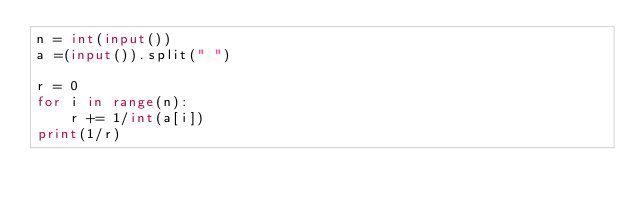<code> <loc_0><loc_0><loc_500><loc_500><_Python_>n = int(input())
a =(input()).split(" ")

r = 0
for i in range(n):
    r += 1/int(a[i])
print(1/r)</code> 